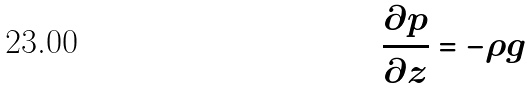Convert formula to latex. <formula><loc_0><loc_0><loc_500><loc_500>\frac { \partial p } { \partial z } = - \rho g</formula> 